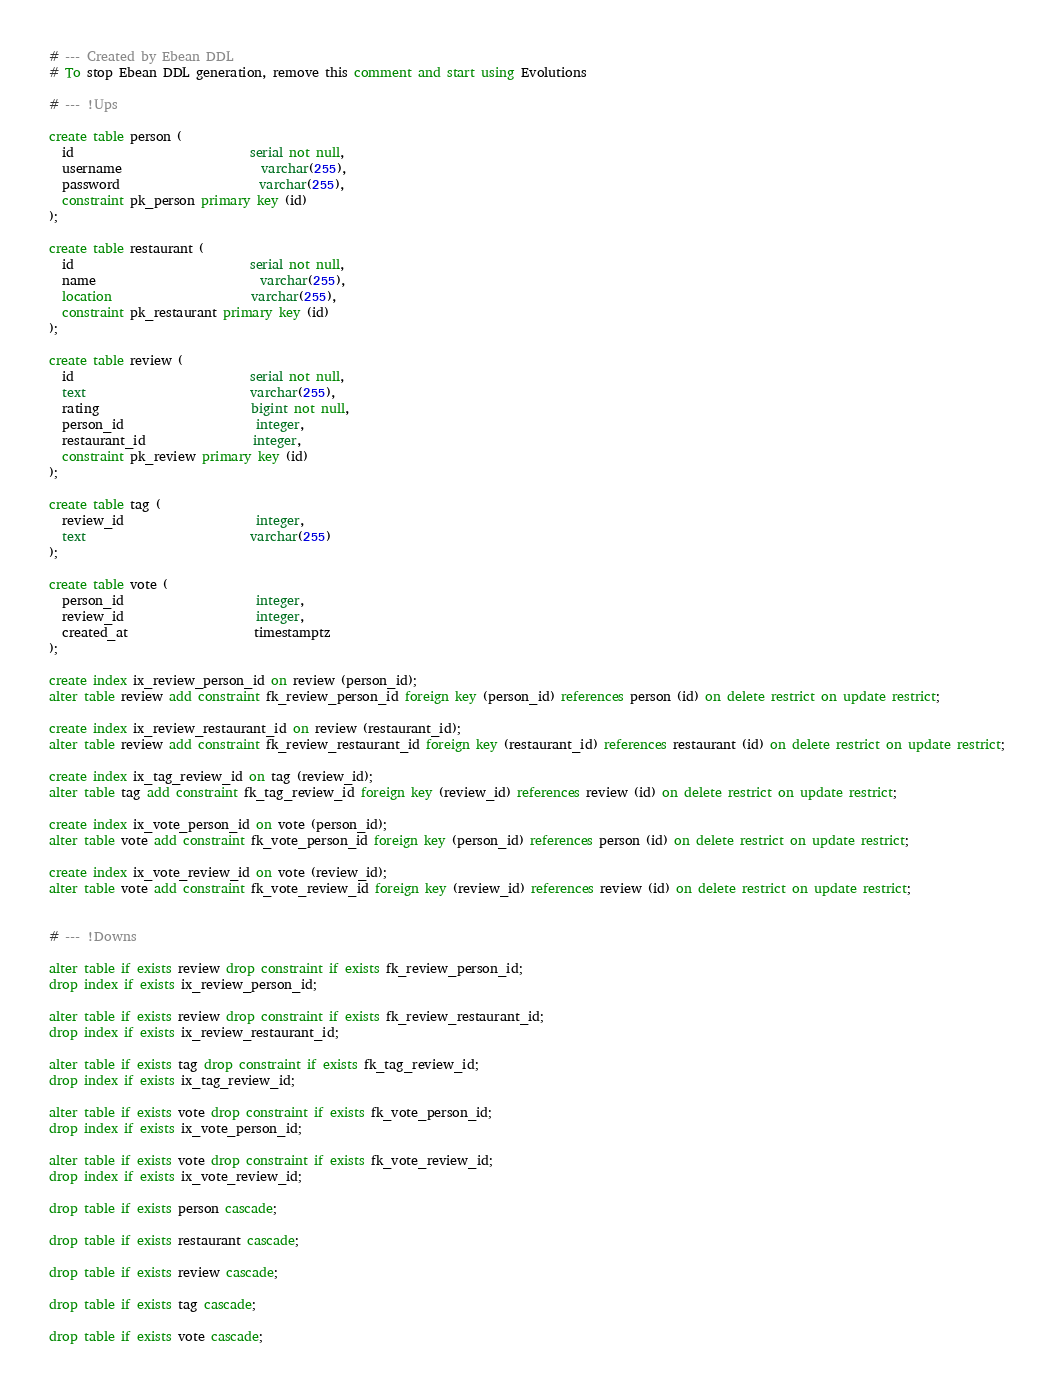<code> <loc_0><loc_0><loc_500><loc_500><_SQL_># --- Created by Ebean DDL
# To stop Ebean DDL generation, remove this comment and start using Evolutions

# --- !Ups

create table person (
  id                            serial not null,
  username                      varchar(255),
  password                      varchar(255),
  constraint pk_person primary key (id)
);

create table restaurant (
  id                            serial not null,
  name                          varchar(255),
  location                      varchar(255),
  constraint pk_restaurant primary key (id)
);

create table review (
  id                            serial not null,
  text                          varchar(255),
  rating                        bigint not null,
  person_id                     integer,
  restaurant_id                 integer,
  constraint pk_review primary key (id)
);

create table tag (
  review_id                     integer,
  text                          varchar(255)
);

create table vote (
  person_id                     integer,
  review_id                     integer,
  created_at                    timestamptz
);

create index ix_review_person_id on review (person_id);
alter table review add constraint fk_review_person_id foreign key (person_id) references person (id) on delete restrict on update restrict;

create index ix_review_restaurant_id on review (restaurant_id);
alter table review add constraint fk_review_restaurant_id foreign key (restaurant_id) references restaurant (id) on delete restrict on update restrict;

create index ix_tag_review_id on tag (review_id);
alter table tag add constraint fk_tag_review_id foreign key (review_id) references review (id) on delete restrict on update restrict;

create index ix_vote_person_id on vote (person_id);
alter table vote add constraint fk_vote_person_id foreign key (person_id) references person (id) on delete restrict on update restrict;

create index ix_vote_review_id on vote (review_id);
alter table vote add constraint fk_vote_review_id foreign key (review_id) references review (id) on delete restrict on update restrict;


# --- !Downs

alter table if exists review drop constraint if exists fk_review_person_id;
drop index if exists ix_review_person_id;

alter table if exists review drop constraint if exists fk_review_restaurant_id;
drop index if exists ix_review_restaurant_id;

alter table if exists tag drop constraint if exists fk_tag_review_id;
drop index if exists ix_tag_review_id;

alter table if exists vote drop constraint if exists fk_vote_person_id;
drop index if exists ix_vote_person_id;

alter table if exists vote drop constraint if exists fk_vote_review_id;
drop index if exists ix_vote_review_id;

drop table if exists person cascade;

drop table if exists restaurant cascade;

drop table if exists review cascade;

drop table if exists tag cascade;

drop table if exists vote cascade;

</code> 